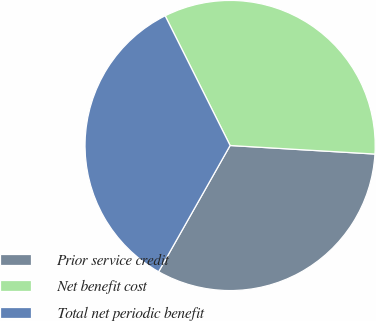<chart> <loc_0><loc_0><loc_500><loc_500><pie_chart><fcel>Prior service credit<fcel>Net benefit cost<fcel>Total net periodic benefit<nl><fcel>32.26%<fcel>33.33%<fcel>34.41%<nl></chart> 